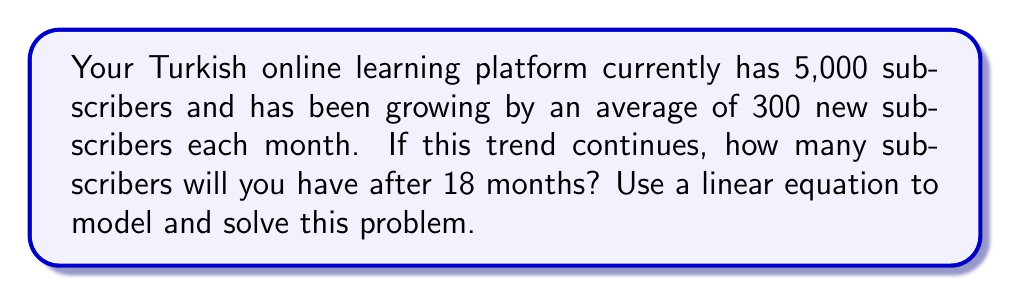Teach me how to tackle this problem. Let's approach this step-by-step:

1) First, we need to define our variables:
   Let $x$ = number of months
   Let $y$ = number of subscribers

2) We can now create a linear equation in the form $y = mx + b$, where:
   $m$ = slope (rate of change) = 300 subscribers per month
   $b$ = y-intercept (initial number of subscribers) = 5,000

3) Our linear equation is:
   $y = 300x + 5000$

4) We want to know the number of subscribers after 18 months, so we substitute $x = 18$:

   $y = 300(18) + 5000$

5) Let's solve this equation:
   $y = 5400 + 5000$
   $y = 10400$

Therefore, after 18 months, the platform is predicted to have 10,400 subscribers.
Answer: 10,400 subscribers 